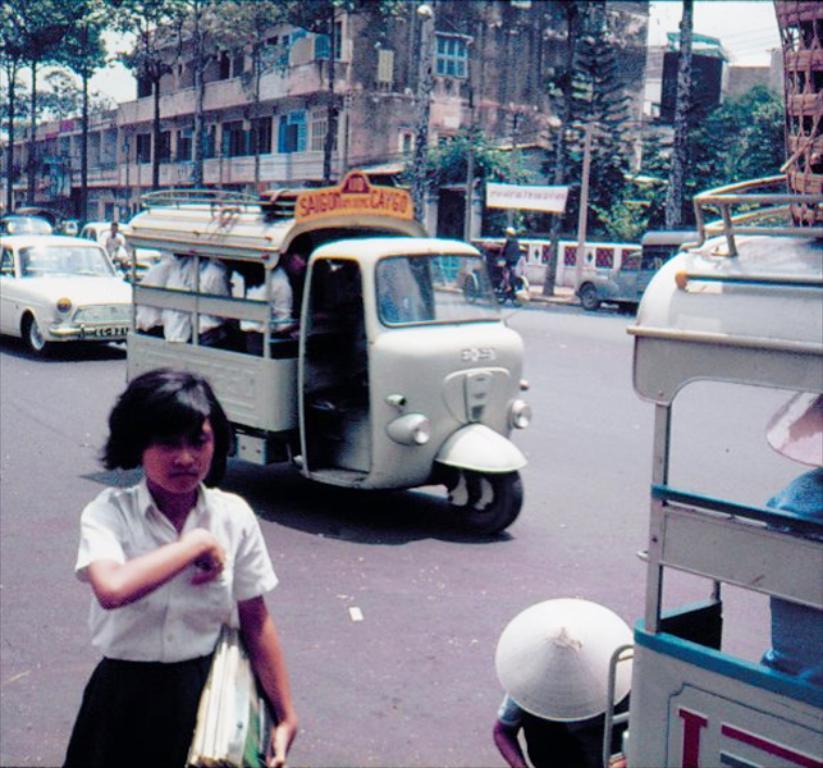Could you give a brief overview of what you see in this image? As we can see in the image there are cars, motorcycles, few people, buildings, banner and trees. At the top there is sky. The girl walking in the front is wearing white color shirt and holding books. 